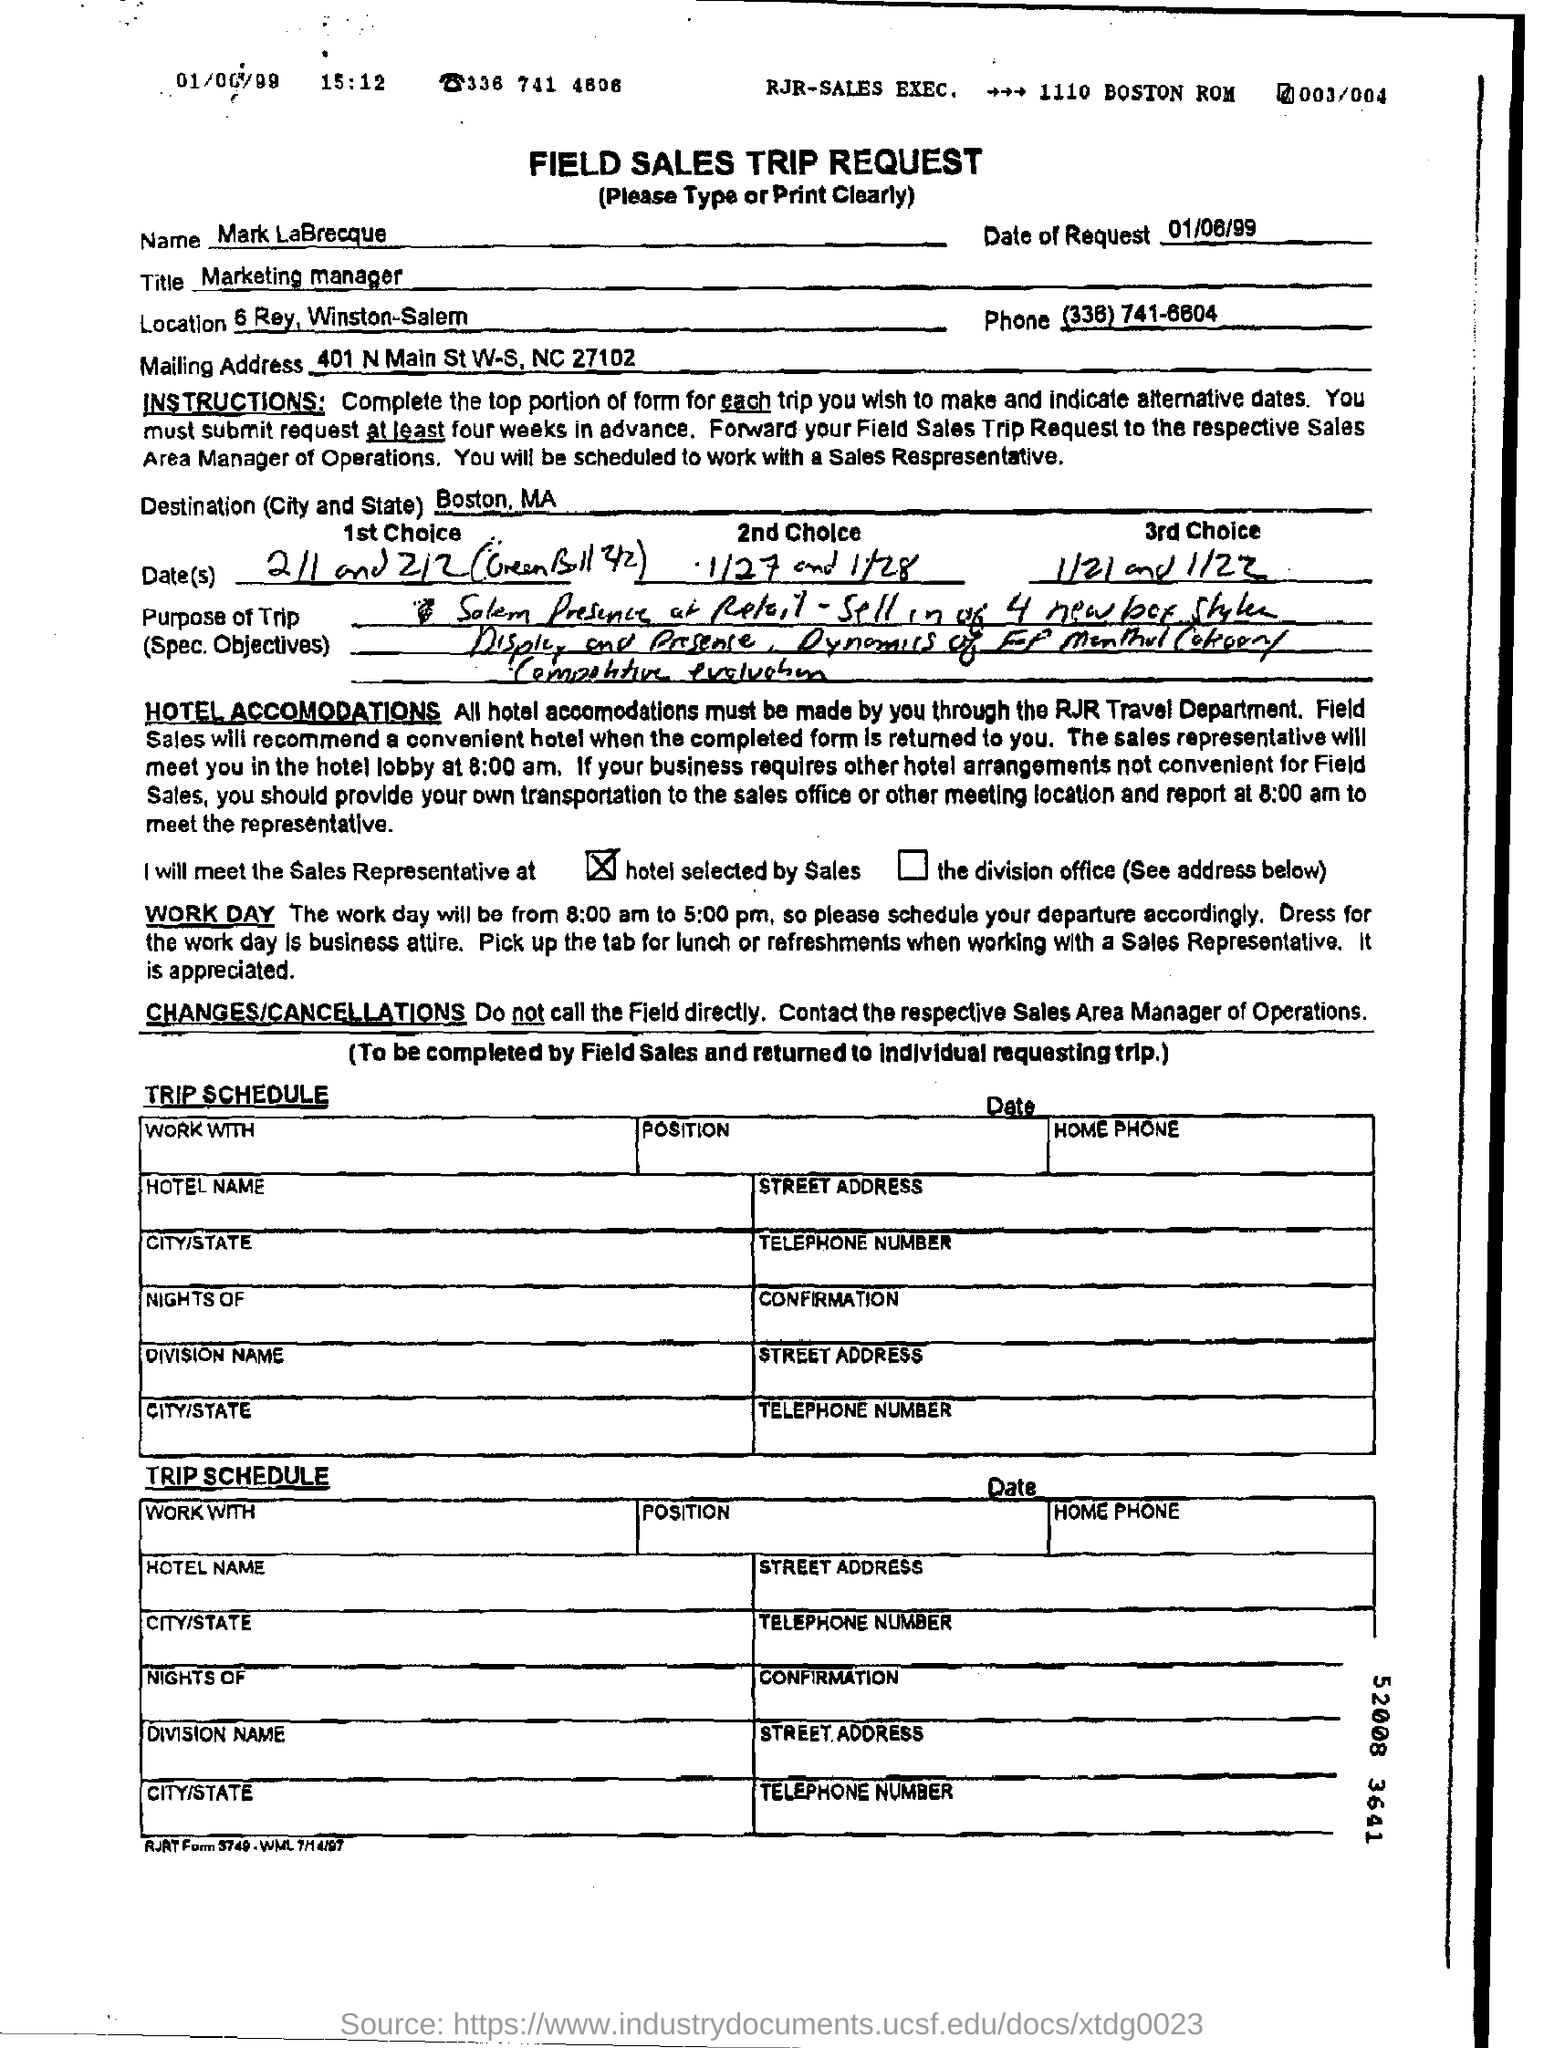What is the name of the title mentioned ?
Keep it short and to the point. Marketing manager. What is the date of request mentioned ?
Give a very brief answer. 01/06/99. What is the destination (city and state ) mentioned ?
Make the answer very short. Boston , ma. 